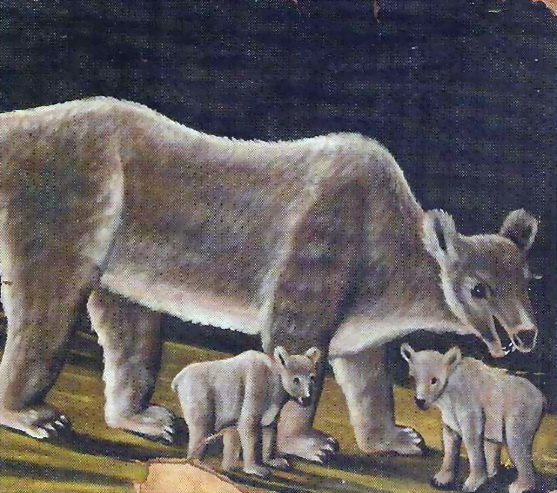Describe the following image. The image portrays an endearing scene from wildlife art featuring a mother bear with her two cubs. The mother bear, stout and strong, stands on all fours, exuding a protective presence. Her cubs add an element of playful innocence as they stand on their hind legs, exploring their surroundings with curious eyes. The background features a rich, dark blue color with a hint of green emerging from the lower left corner, giving the composition depth and a mysterious aura. The art style is highly realistic, meticulously capturing the fine details of the bears' fur and the natural setting. 